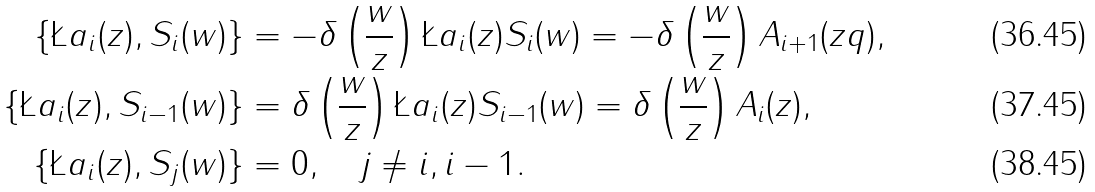<formula> <loc_0><loc_0><loc_500><loc_500>\{ \L a _ { i } ( z ) , S _ { i } ( w ) \} & = - \delta \left ( \frac { w } { z } \right ) \L a _ { i } ( z ) S _ { i } ( w ) = - \delta \left ( \frac { w } { z } \right ) A _ { i + 1 } ( z q ) , \\ \{ \L a _ { i } ( z ) , S _ { i - 1 } ( w ) \} & = \delta \left ( \frac { w } { z } \right ) \L a _ { i } ( z ) S _ { i - 1 } ( w ) = \delta \left ( \frac { w } { z } \right ) A _ { i } ( z ) , \\ \{ \L a _ { i } ( z ) , S _ { j } ( w ) \} & = 0 , \quad j \neq i , i - 1 .</formula> 